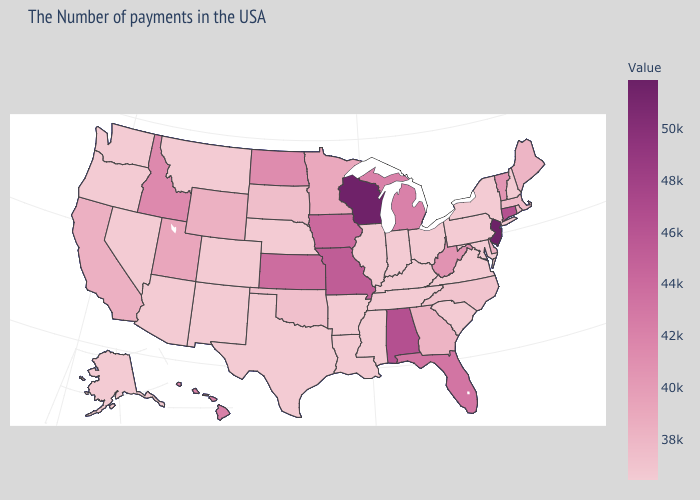Is the legend a continuous bar?
Answer briefly. Yes. Does the map have missing data?
Answer briefly. No. Which states have the highest value in the USA?
Concise answer only. New Jersey. Among the states that border Oregon , which have the highest value?
Answer briefly. Idaho. 